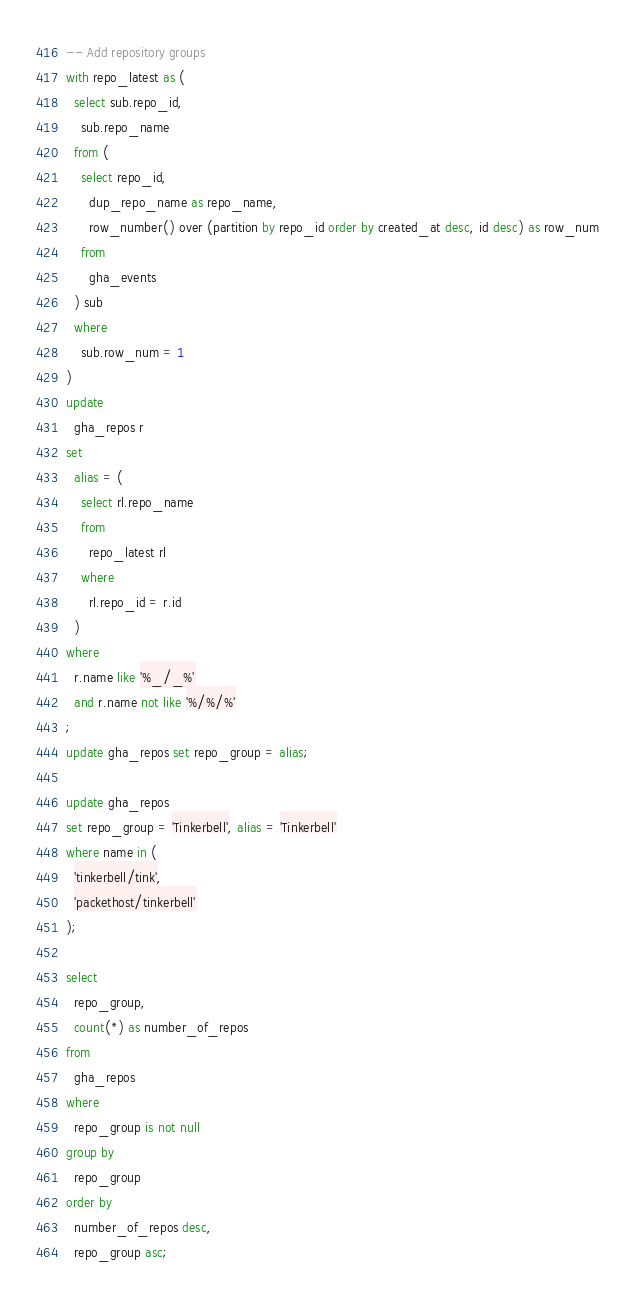Convert code to text. <code><loc_0><loc_0><loc_500><loc_500><_SQL_>-- Add repository groups
with repo_latest as (
  select sub.repo_id,
    sub.repo_name
  from (
    select repo_id,
      dup_repo_name as repo_name,
      row_number() over (partition by repo_id order by created_at desc, id desc) as row_num
    from
      gha_events
  ) sub
  where
    sub.row_num = 1
)
update
  gha_repos r
set
  alias = (
    select rl.repo_name
    from
      repo_latest rl
    where
      rl.repo_id = r.id
  )
where
  r.name like '%_/_%'
  and r.name not like '%/%/%'
;
update gha_repos set repo_group = alias;

update gha_repos
set repo_group = 'Tinkerbell', alias = 'Tinkerbell'
where name in (
  'tinkerbell/tink',
  'packethost/tinkerbell'
);

select
  repo_group,
  count(*) as number_of_repos
from
  gha_repos
where
  repo_group is not null
group by
  repo_group
order by
  number_of_repos desc,
  repo_group asc;
</code> 